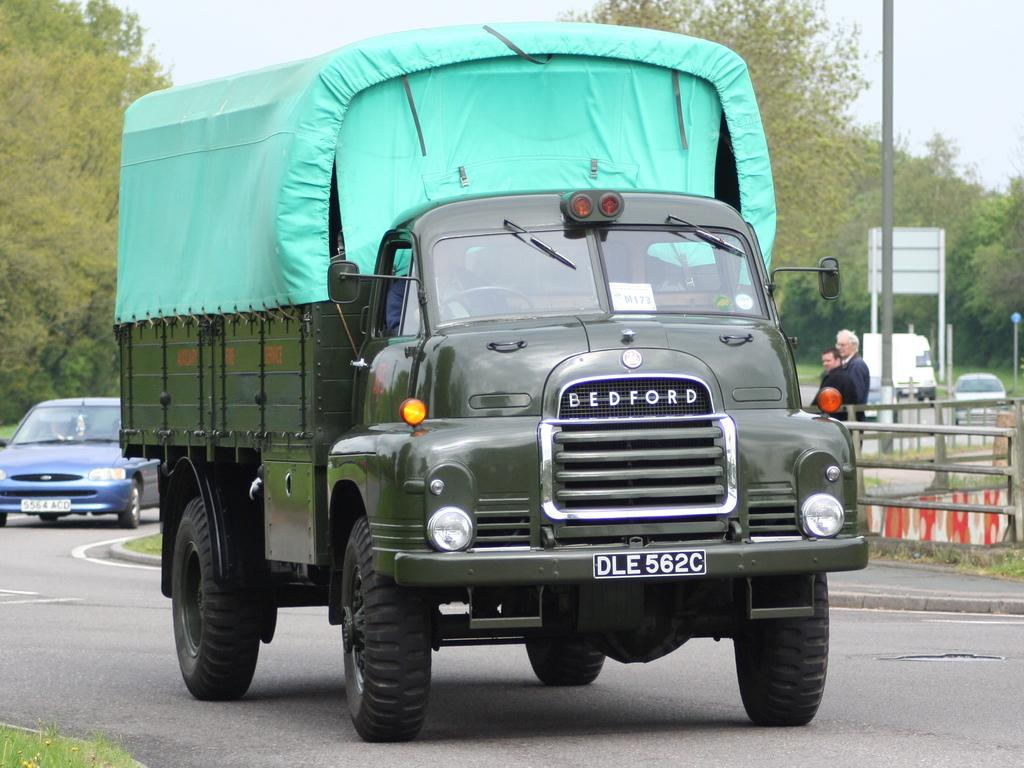What can be seen on the road in the image? There are vehicles on the road in the image. How many people are standing in the image? There are two persons standing in the image. What objects are present in the image besides the vehicles and people? There are poles and trees in the image. What is visible in the background of the image? The sky is visible in the background of the image. What type of prose is being recited by the flock of birds in the image? There are no birds present in the image, and therefore no prose being recited. How much sugar is visible in the image? There is no sugar visible in the image. 